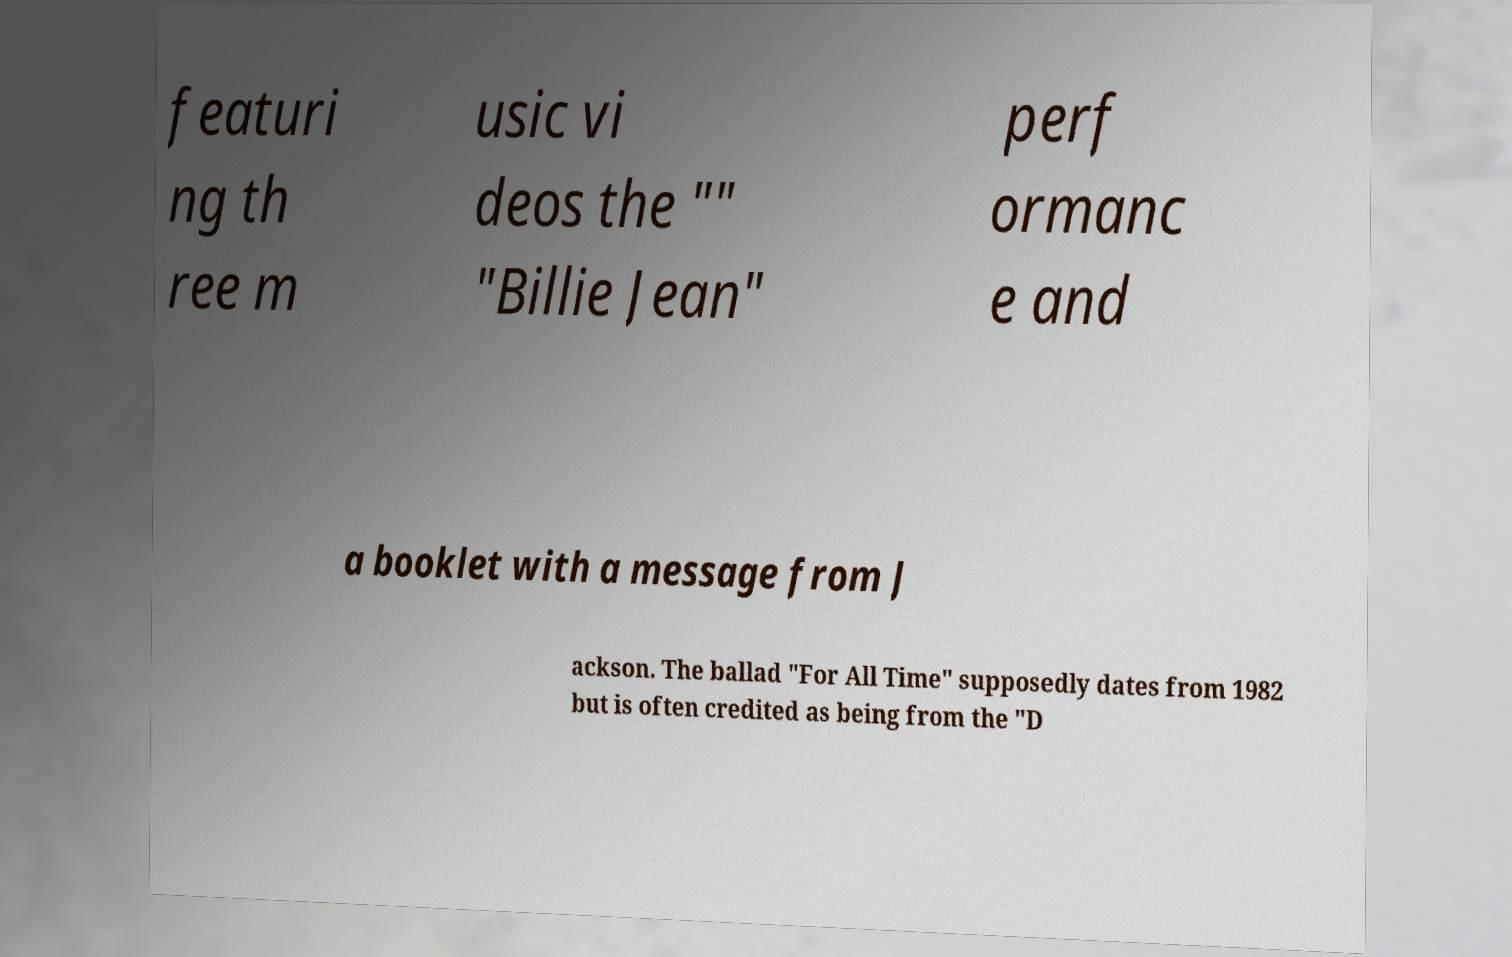Could you assist in decoding the text presented in this image and type it out clearly? featuri ng th ree m usic vi deos the "" "Billie Jean" perf ormanc e and a booklet with a message from J ackson. The ballad "For All Time" supposedly dates from 1982 but is often credited as being from the "D 